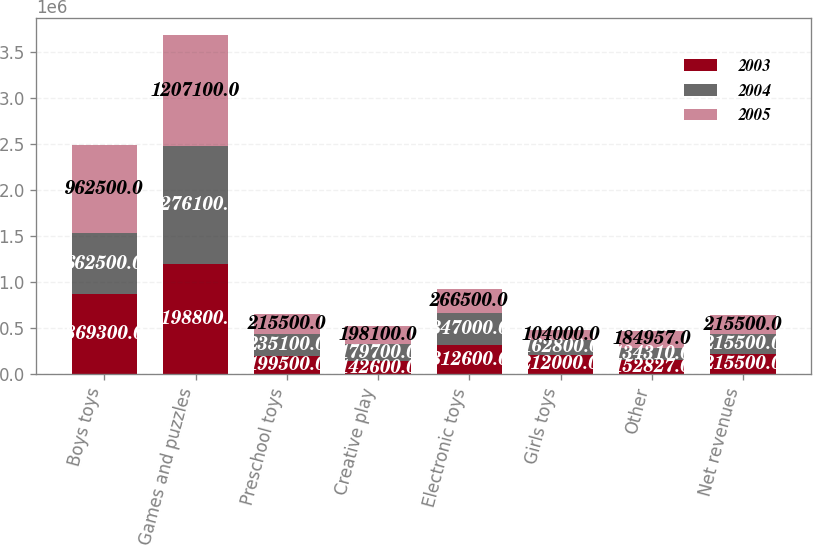Convert chart to OTSL. <chart><loc_0><loc_0><loc_500><loc_500><stacked_bar_chart><ecel><fcel>Boys toys<fcel>Games and puzzles<fcel>Preschool toys<fcel>Creative play<fcel>Electronic toys<fcel>Girls toys<fcel>Other<fcel>Net revenues<nl><fcel>2003<fcel>869300<fcel>1.1988e+06<fcel>199500<fcel>142600<fcel>312600<fcel>212000<fcel>152827<fcel>215500<nl><fcel>2004<fcel>662500<fcel>1.2761e+06<fcel>235100<fcel>179700<fcel>347000<fcel>162800<fcel>134310<fcel>215500<nl><fcel>2005<fcel>962500<fcel>1.2071e+06<fcel>215500<fcel>198100<fcel>266500<fcel>104000<fcel>184957<fcel>215500<nl></chart> 